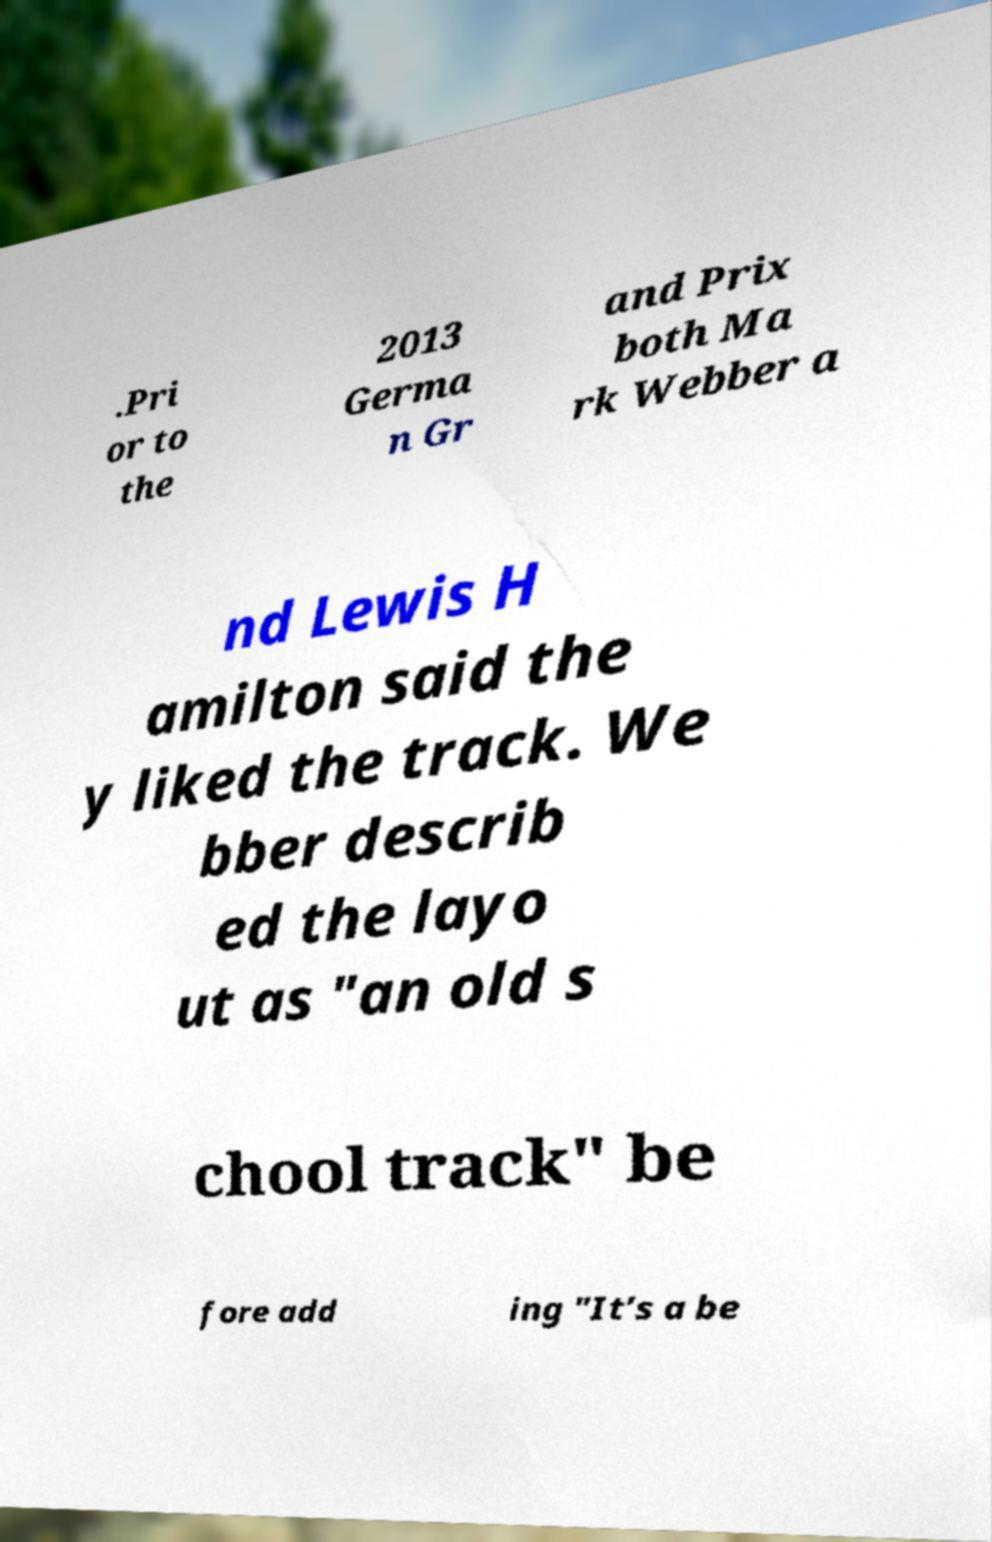Can you accurately transcribe the text from the provided image for me? .Pri or to the 2013 Germa n Gr and Prix both Ma rk Webber a nd Lewis H amilton said the y liked the track. We bber describ ed the layo ut as "an old s chool track" be fore add ing "It’s a be 